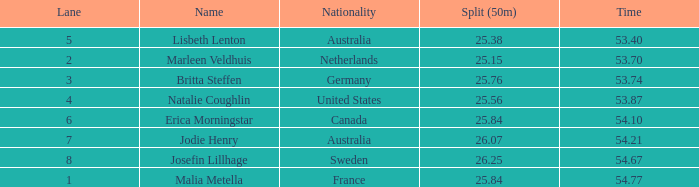What is the slowest 50m split time for a total of 53.74 in a lane of less than 3? None. 